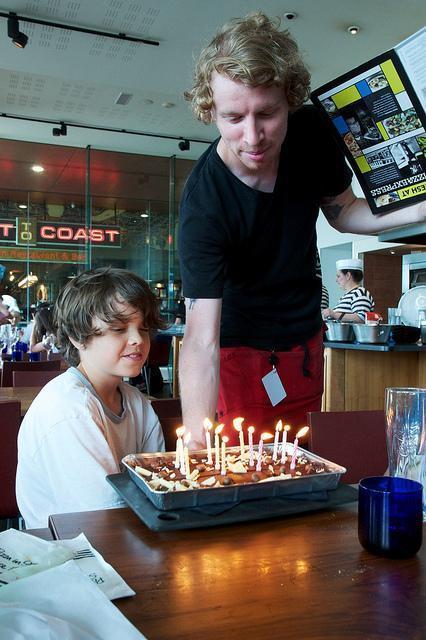How many candles are there?
Give a very brief answer. 12. How many people are looking at the cake right now?
Give a very brief answer. 2. How many people are there?
Give a very brief answer. 2. How many cups can you see?
Give a very brief answer. 2. How many umbrellas with yellow stripes are on the beach?
Give a very brief answer. 0. 